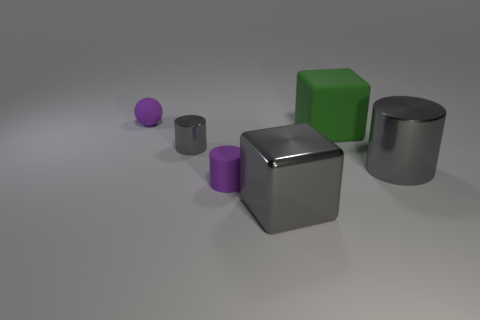Add 4 small gray cylinders. How many objects exist? 10 Subtract all big gray cylinders. How many cylinders are left? 2 Subtract 1 green cubes. How many objects are left? 5 Subtract all balls. How many objects are left? 5 Subtract 1 balls. How many balls are left? 0 Subtract all cyan spheres. Subtract all brown cylinders. How many spheres are left? 1 Subtract all green blocks. How many gray cylinders are left? 2 Subtract all large blocks. Subtract all large green matte objects. How many objects are left? 3 Add 5 small purple rubber objects. How many small purple rubber objects are left? 7 Add 5 big cubes. How many big cubes exist? 7 